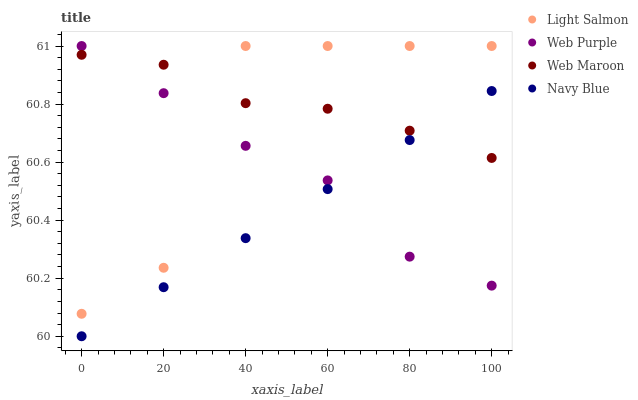Does Navy Blue have the minimum area under the curve?
Answer yes or no. Yes. Does Web Maroon have the maximum area under the curve?
Answer yes or no. Yes. Does Light Salmon have the minimum area under the curve?
Answer yes or no. No. Does Light Salmon have the maximum area under the curve?
Answer yes or no. No. Is Navy Blue the smoothest?
Answer yes or no. Yes. Is Light Salmon the roughest?
Answer yes or no. Yes. Is Web Maroon the smoothest?
Answer yes or no. No. Is Web Maroon the roughest?
Answer yes or no. No. Does Navy Blue have the lowest value?
Answer yes or no. Yes. Does Light Salmon have the lowest value?
Answer yes or no. No. Does Web Purple have the highest value?
Answer yes or no. Yes. Does Web Maroon have the highest value?
Answer yes or no. No. Is Navy Blue less than Light Salmon?
Answer yes or no. Yes. Is Light Salmon greater than Navy Blue?
Answer yes or no. Yes. Does Web Purple intersect Web Maroon?
Answer yes or no. Yes. Is Web Purple less than Web Maroon?
Answer yes or no. No. Is Web Purple greater than Web Maroon?
Answer yes or no. No. Does Navy Blue intersect Light Salmon?
Answer yes or no. No. 